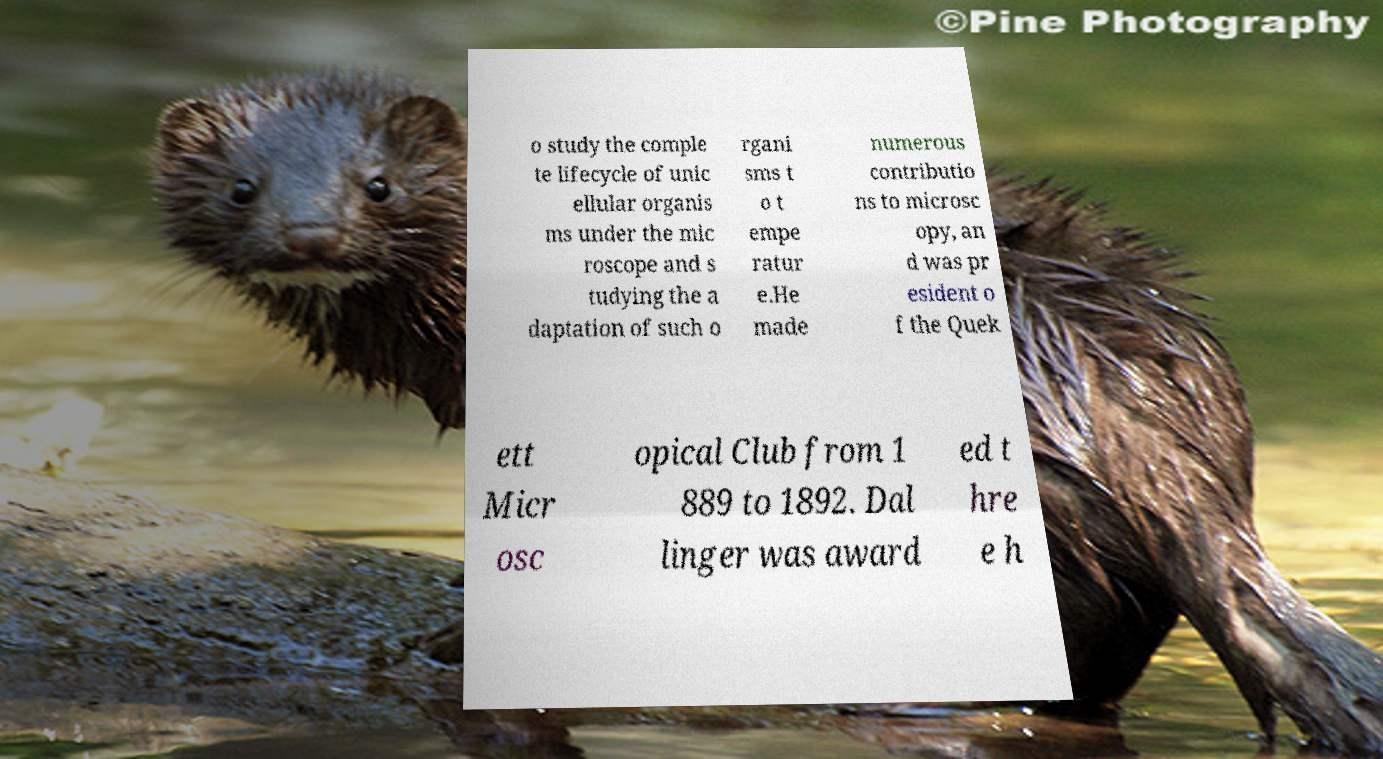Can you read and provide the text displayed in the image?This photo seems to have some interesting text. Can you extract and type it out for me? o study the comple te lifecycle of unic ellular organis ms under the mic roscope and s tudying the a daptation of such o rgani sms t o t empe ratur e.He made numerous contributio ns to microsc opy, an d was pr esident o f the Quek ett Micr osc opical Club from 1 889 to 1892. Dal linger was award ed t hre e h 